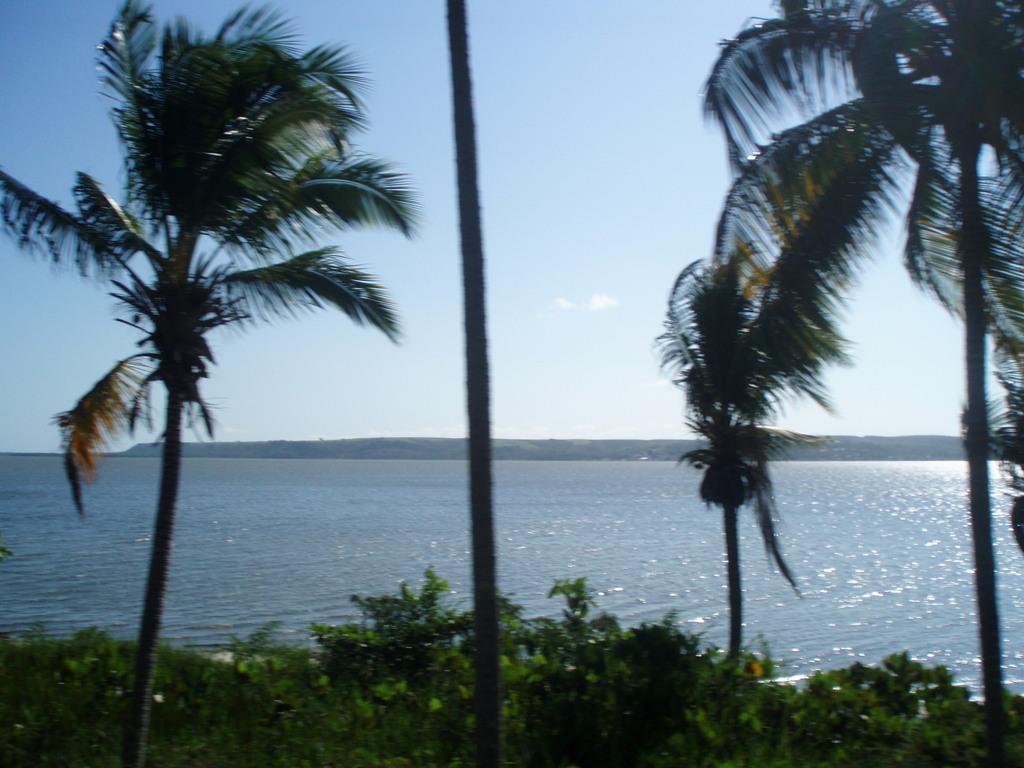Can you describe this image briefly? In this picture I can observe trees. In the bottom of the picture I can observe plants. In the background I can observe a river and sky. 